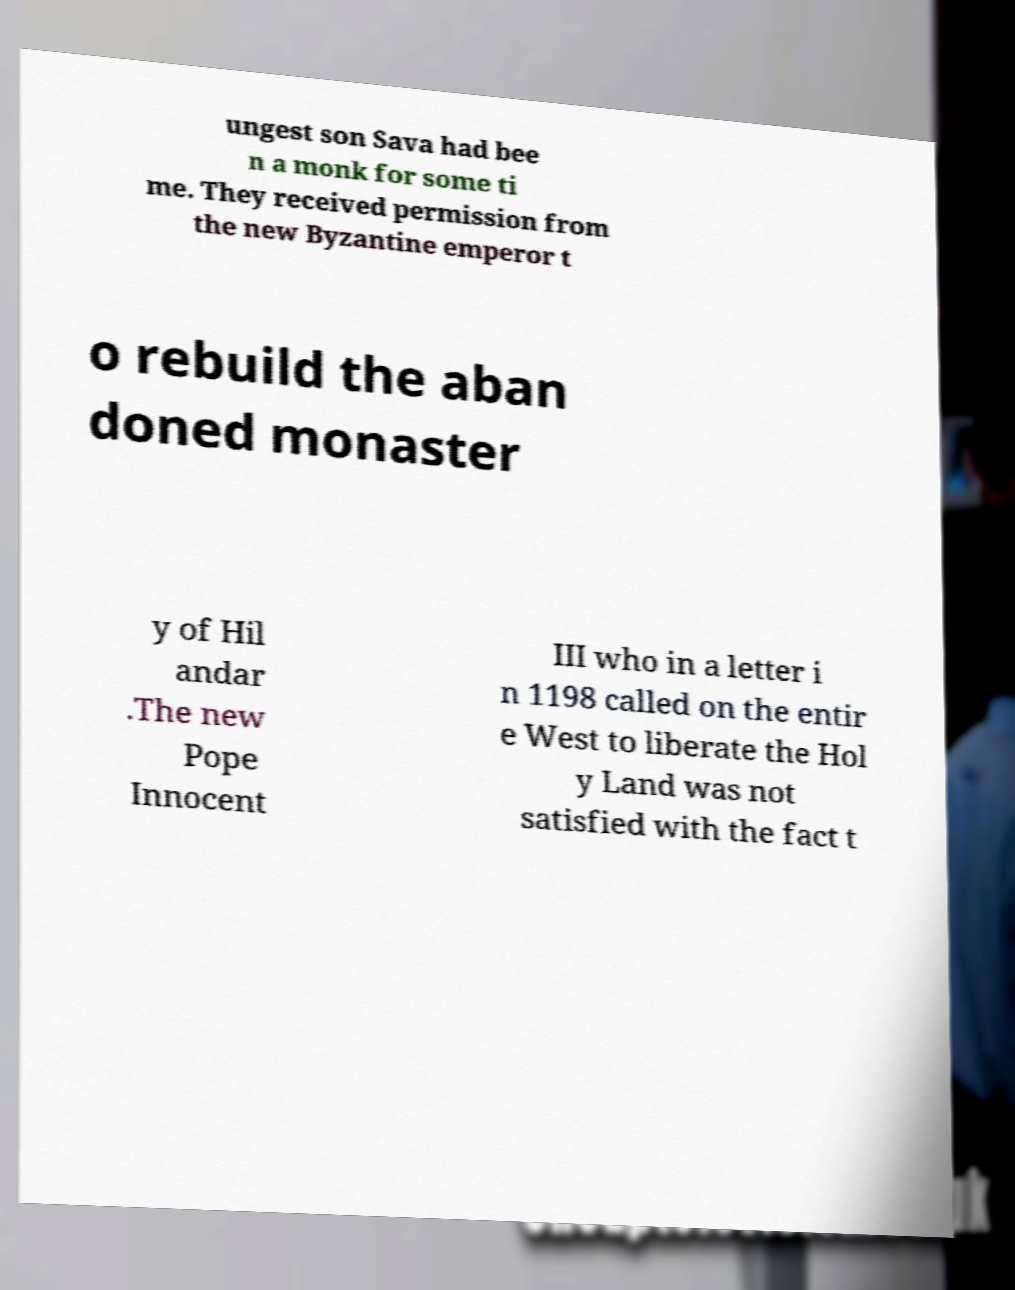Can you accurately transcribe the text from the provided image for me? ungest son Sava had bee n a monk for some ti me. They received permission from the new Byzantine emperor t o rebuild the aban doned monaster y of Hil andar .The new Pope Innocent III who in a letter i n 1198 called on the entir e West to liberate the Hol y Land was not satisfied with the fact t 